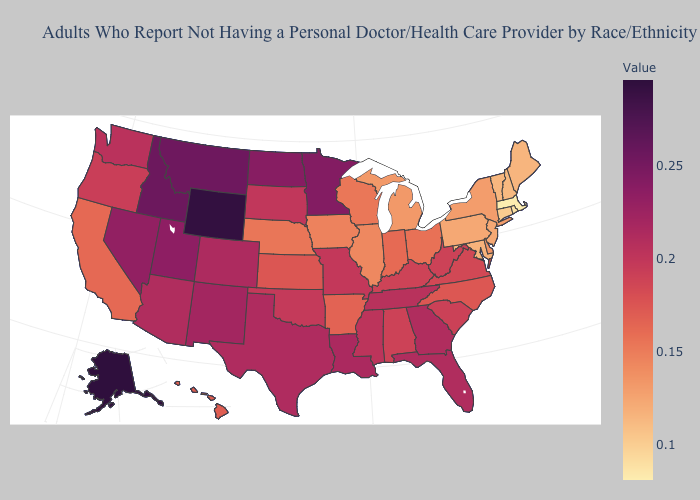Which states have the lowest value in the USA?
Keep it brief. Massachusetts. Which states hav the highest value in the South?
Write a very short answer. Louisiana. Among the states that border Michigan , does Ohio have the lowest value?
Answer briefly. No. Does Alabama have a higher value than Arizona?
Short answer required. No. Does Rhode Island have the highest value in the USA?
Give a very brief answer. No. Among the states that border Oklahoma , which have the lowest value?
Quick response, please. Arkansas. 